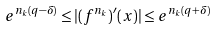<formula> <loc_0><loc_0><loc_500><loc_500>e ^ { n _ { k } ( q - \delta ) } \leq | ( f ^ { n _ { k } } ) ^ { \prime } ( x ) | \leq e ^ { n _ { k } ( q + \delta ) }</formula> 